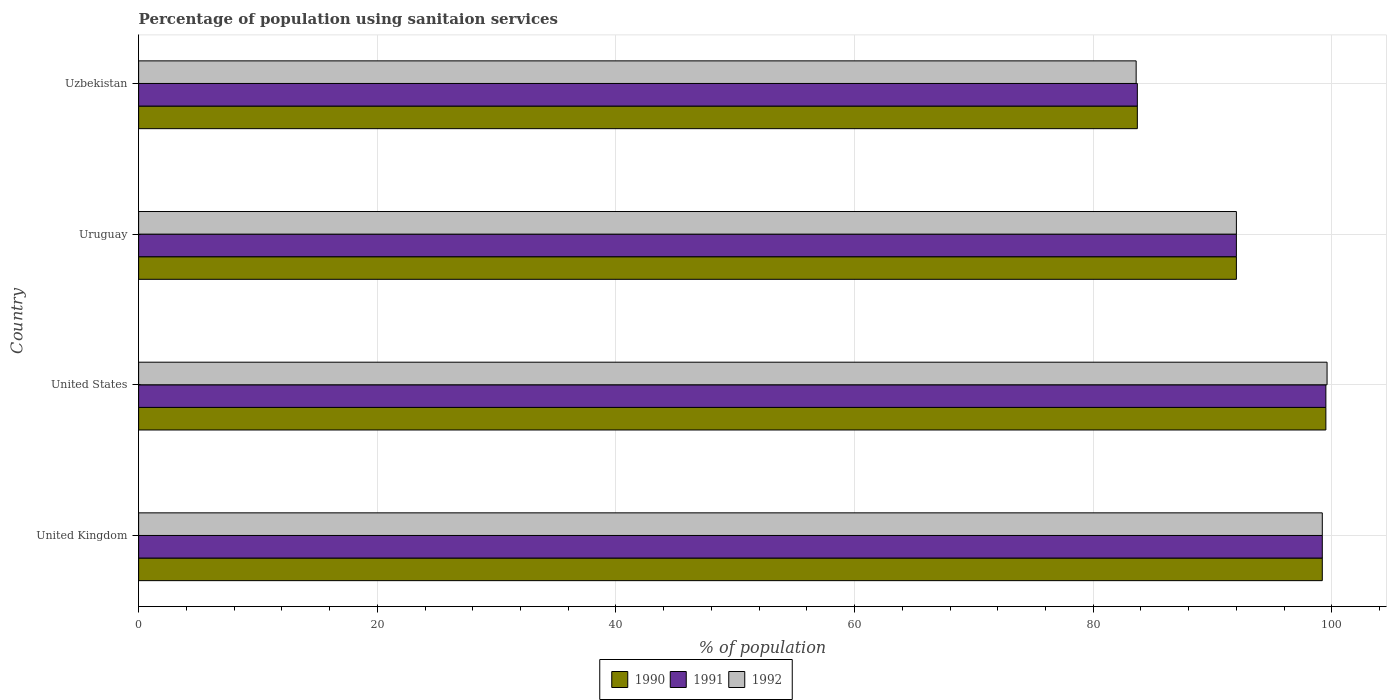How many groups of bars are there?
Provide a short and direct response. 4. Are the number of bars per tick equal to the number of legend labels?
Ensure brevity in your answer.  Yes. Are the number of bars on each tick of the Y-axis equal?
Provide a succinct answer. Yes. How many bars are there on the 2nd tick from the bottom?
Make the answer very short. 3. What is the label of the 2nd group of bars from the top?
Your answer should be very brief. Uruguay. In how many cases, is the number of bars for a given country not equal to the number of legend labels?
Make the answer very short. 0. What is the percentage of population using sanitaion services in 1991 in United States?
Your response must be concise. 99.5. Across all countries, what is the maximum percentage of population using sanitaion services in 1990?
Ensure brevity in your answer.  99.5. Across all countries, what is the minimum percentage of population using sanitaion services in 1991?
Your response must be concise. 83.7. In which country was the percentage of population using sanitaion services in 1992 maximum?
Your answer should be very brief. United States. In which country was the percentage of population using sanitaion services in 1992 minimum?
Provide a short and direct response. Uzbekistan. What is the total percentage of population using sanitaion services in 1990 in the graph?
Offer a terse response. 374.4. What is the difference between the percentage of population using sanitaion services in 1991 in United States and that in Uzbekistan?
Provide a short and direct response. 15.8. What is the difference between the percentage of population using sanitaion services in 1990 in United Kingdom and the percentage of population using sanitaion services in 1992 in Uruguay?
Ensure brevity in your answer.  7.2. What is the average percentage of population using sanitaion services in 1991 per country?
Provide a short and direct response. 93.6. What is the difference between the percentage of population using sanitaion services in 1990 and percentage of population using sanitaion services in 1991 in United Kingdom?
Provide a succinct answer. 0. What is the ratio of the percentage of population using sanitaion services in 1992 in United Kingdom to that in United States?
Offer a terse response. 1. Is the percentage of population using sanitaion services in 1991 in United Kingdom less than that in Uzbekistan?
Offer a terse response. No. Is the difference between the percentage of population using sanitaion services in 1990 in Uruguay and Uzbekistan greater than the difference between the percentage of population using sanitaion services in 1991 in Uruguay and Uzbekistan?
Provide a succinct answer. No. What is the difference between the highest and the second highest percentage of population using sanitaion services in 1992?
Keep it short and to the point. 0.4. What is the difference between the highest and the lowest percentage of population using sanitaion services in 1992?
Your answer should be very brief. 16. Is the sum of the percentage of population using sanitaion services in 1990 in United Kingdom and United States greater than the maximum percentage of population using sanitaion services in 1991 across all countries?
Make the answer very short. Yes. What does the 1st bar from the bottom in United States represents?
Keep it short and to the point. 1990. How many bars are there?
Ensure brevity in your answer.  12. How many countries are there in the graph?
Provide a short and direct response. 4. Are the values on the major ticks of X-axis written in scientific E-notation?
Your response must be concise. No. Does the graph contain grids?
Your answer should be very brief. Yes. How many legend labels are there?
Offer a terse response. 3. How are the legend labels stacked?
Make the answer very short. Horizontal. What is the title of the graph?
Ensure brevity in your answer.  Percentage of population using sanitaion services. What is the label or title of the X-axis?
Your response must be concise. % of population. What is the label or title of the Y-axis?
Provide a succinct answer. Country. What is the % of population of 1990 in United Kingdom?
Make the answer very short. 99.2. What is the % of population in 1991 in United Kingdom?
Your answer should be very brief. 99.2. What is the % of population in 1992 in United Kingdom?
Provide a succinct answer. 99.2. What is the % of population in 1990 in United States?
Give a very brief answer. 99.5. What is the % of population of 1991 in United States?
Your response must be concise. 99.5. What is the % of population of 1992 in United States?
Your answer should be compact. 99.6. What is the % of population in 1990 in Uruguay?
Your answer should be very brief. 92. What is the % of population of 1991 in Uruguay?
Ensure brevity in your answer.  92. What is the % of population of 1992 in Uruguay?
Provide a short and direct response. 92. What is the % of population of 1990 in Uzbekistan?
Keep it short and to the point. 83.7. What is the % of population of 1991 in Uzbekistan?
Provide a succinct answer. 83.7. What is the % of population of 1992 in Uzbekistan?
Your answer should be very brief. 83.6. Across all countries, what is the maximum % of population of 1990?
Offer a very short reply. 99.5. Across all countries, what is the maximum % of population of 1991?
Provide a succinct answer. 99.5. Across all countries, what is the maximum % of population in 1992?
Make the answer very short. 99.6. Across all countries, what is the minimum % of population in 1990?
Your answer should be compact. 83.7. Across all countries, what is the minimum % of population in 1991?
Your answer should be compact. 83.7. Across all countries, what is the minimum % of population of 1992?
Give a very brief answer. 83.6. What is the total % of population of 1990 in the graph?
Your answer should be compact. 374.4. What is the total % of population of 1991 in the graph?
Offer a very short reply. 374.4. What is the total % of population of 1992 in the graph?
Your answer should be compact. 374.4. What is the difference between the % of population in 1990 in United Kingdom and that in United States?
Give a very brief answer. -0.3. What is the difference between the % of population in 1992 in United Kingdom and that in United States?
Offer a very short reply. -0.4. What is the difference between the % of population in 1990 in United Kingdom and that in Uruguay?
Offer a very short reply. 7.2. What is the difference between the % of population in 1991 in United States and that in Uruguay?
Your answer should be compact. 7.5. What is the difference between the % of population in 1990 in United Kingdom and the % of population in 1991 in Uruguay?
Give a very brief answer. 7.2. What is the difference between the % of population of 1990 in United Kingdom and the % of population of 1992 in Uzbekistan?
Your answer should be compact. 15.6. What is the difference between the % of population in 1991 in United Kingdom and the % of population in 1992 in Uzbekistan?
Provide a short and direct response. 15.6. What is the difference between the % of population of 1990 in United States and the % of population of 1991 in Uruguay?
Offer a terse response. 7.5. What is the difference between the % of population of 1990 in Uruguay and the % of population of 1991 in Uzbekistan?
Offer a very short reply. 8.3. What is the average % of population of 1990 per country?
Give a very brief answer. 93.6. What is the average % of population of 1991 per country?
Give a very brief answer. 93.6. What is the average % of population in 1992 per country?
Provide a succinct answer. 93.6. What is the difference between the % of population of 1990 and % of population of 1992 in United Kingdom?
Your answer should be very brief. 0. What is the difference between the % of population of 1991 and % of population of 1992 in United Kingdom?
Make the answer very short. 0. What is the difference between the % of population of 1991 and % of population of 1992 in United States?
Offer a very short reply. -0.1. What is the difference between the % of population in 1990 and % of population in 1992 in Uruguay?
Make the answer very short. 0. What is the difference between the % of population in 1991 and % of population in 1992 in Uruguay?
Provide a short and direct response. 0. What is the difference between the % of population of 1991 and % of population of 1992 in Uzbekistan?
Your answer should be compact. 0.1. What is the ratio of the % of population of 1991 in United Kingdom to that in United States?
Your response must be concise. 1. What is the ratio of the % of population in 1992 in United Kingdom to that in United States?
Provide a succinct answer. 1. What is the ratio of the % of population of 1990 in United Kingdom to that in Uruguay?
Provide a short and direct response. 1.08. What is the ratio of the % of population in 1991 in United Kingdom to that in Uruguay?
Keep it short and to the point. 1.08. What is the ratio of the % of population in 1992 in United Kingdom to that in Uruguay?
Give a very brief answer. 1.08. What is the ratio of the % of population of 1990 in United Kingdom to that in Uzbekistan?
Your answer should be very brief. 1.19. What is the ratio of the % of population in 1991 in United Kingdom to that in Uzbekistan?
Provide a succinct answer. 1.19. What is the ratio of the % of population of 1992 in United Kingdom to that in Uzbekistan?
Provide a succinct answer. 1.19. What is the ratio of the % of population in 1990 in United States to that in Uruguay?
Give a very brief answer. 1.08. What is the ratio of the % of population of 1991 in United States to that in Uruguay?
Your answer should be very brief. 1.08. What is the ratio of the % of population of 1992 in United States to that in Uruguay?
Provide a short and direct response. 1.08. What is the ratio of the % of population of 1990 in United States to that in Uzbekistan?
Provide a short and direct response. 1.19. What is the ratio of the % of population of 1991 in United States to that in Uzbekistan?
Your answer should be very brief. 1.19. What is the ratio of the % of population in 1992 in United States to that in Uzbekistan?
Provide a short and direct response. 1.19. What is the ratio of the % of population of 1990 in Uruguay to that in Uzbekistan?
Your response must be concise. 1.1. What is the ratio of the % of population in 1991 in Uruguay to that in Uzbekistan?
Your answer should be very brief. 1.1. What is the ratio of the % of population in 1992 in Uruguay to that in Uzbekistan?
Provide a short and direct response. 1.1. What is the difference between the highest and the second highest % of population of 1992?
Your response must be concise. 0.4. What is the difference between the highest and the lowest % of population of 1992?
Make the answer very short. 16. 